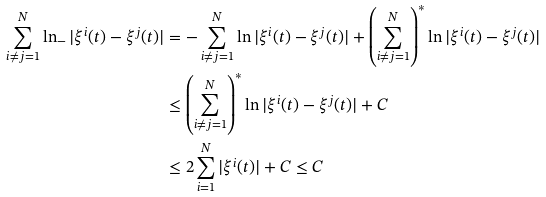Convert formula to latex. <formula><loc_0><loc_0><loc_500><loc_500>\sum _ { i \neq j = 1 } ^ { N } \ln _ { - } | \xi ^ { i } ( t ) - \xi ^ { j } ( t ) | & = - \sum _ { i \neq j = 1 } ^ { N } \ln | \xi ^ { i } ( t ) - \xi ^ { j } ( t ) | + \left ( \sum _ { i \neq j = 1 } ^ { N } \right ) ^ { * } \ln | \xi ^ { i } ( t ) - \xi ^ { j } ( t ) | \\ & \leq \left ( \sum _ { i \neq j = 1 } ^ { N } \right ) ^ { * } \ln | \xi ^ { i } ( t ) - \xi ^ { j } ( t ) | + C \\ & \leq 2 \sum _ { i = 1 } ^ { N } | \xi ^ { i } ( t ) | + C \leq C</formula> 